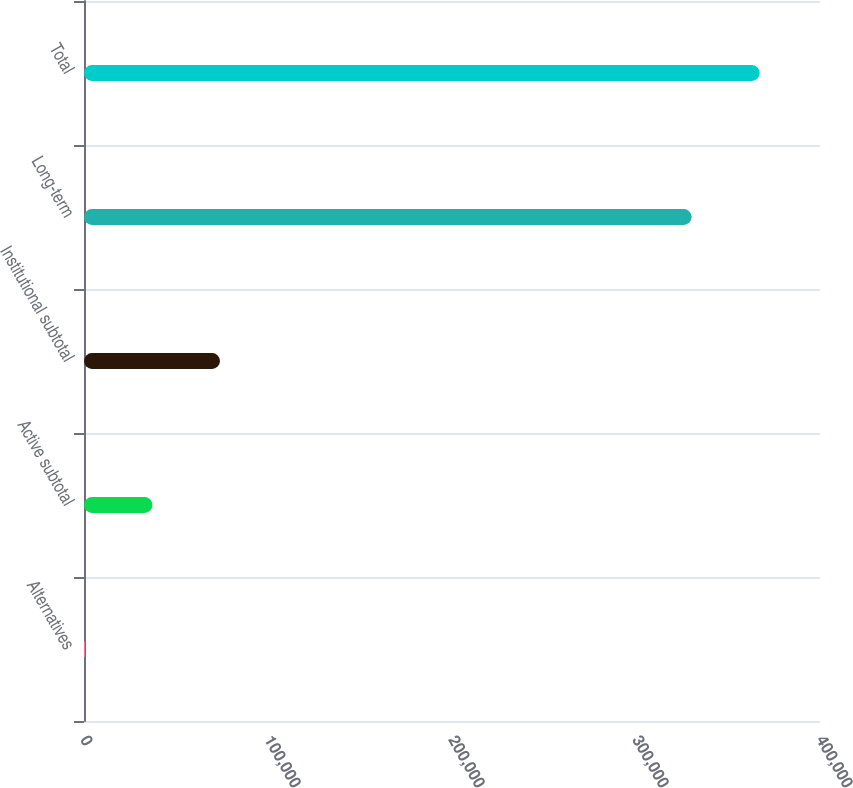<chart> <loc_0><loc_0><loc_500><loc_500><bar_chart><fcel>Alternatives<fcel>Active subtotal<fcel>Institutional subtotal<fcel>Long-term<fcel>Total<nl><fcel>566<fcel>37234.8<fcel>73903.6<fcel>330240<fcel>367254<nl></chart> 